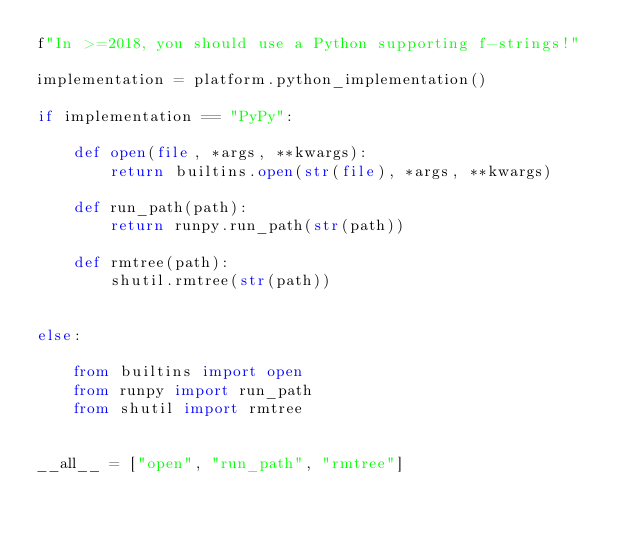<code> <loc_0><loc_0><loc_500><loc_500><_Python_>f"In >=2018, you should use a Python supporting f-strings!"

implementation = platform.python_implementation()

if implementation == "PyPy":

    def open(file, *args, **kwargs):
        return builtins.open(str(file), *args, **kwargs)

    def run_path(path):
        return runpy.run_path(str(path))

    def rmtree(path):
        shutil.rmtree(str(path))


else:

    from builtins import open
    from runpy import run_path
    from shutil import rmtree


__all__ = ["open", "run_path", "rmtree"]
</code> 